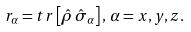<formula> <loc_0><loc_0><loc_500><loc_500>r _ { \alpha } = t r \left [ \hat { \rho } \, \hat { \sigma } _ { \alpha } \right ] , \, \alpha = x , y , z .</formula> 